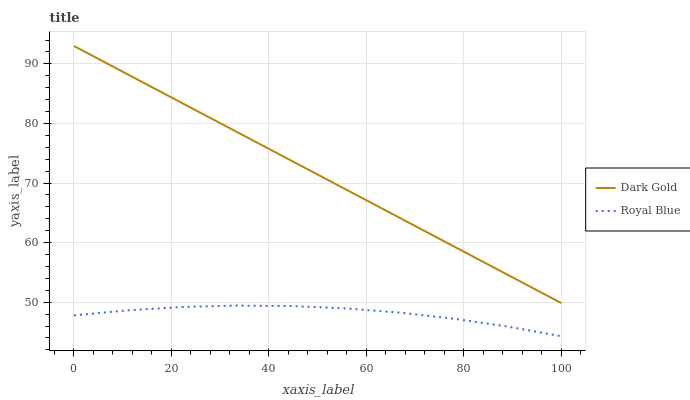Does Dark Gold have the minimum area under the curve?
Answer yes or no. No. Is Dark Gold the roughest?
Answer yes or no. No. Does Dark Gold have the lowest value?
Answer yes or no. No. Is Royal Blue less than Dark Gold?
Answer yes or no. Yes. Is Dark Gold greater than Royal Blue?
Answer yes or no. Yes. Does Royal Blue intersect Dark Gold?
Answer yes or no. No. 